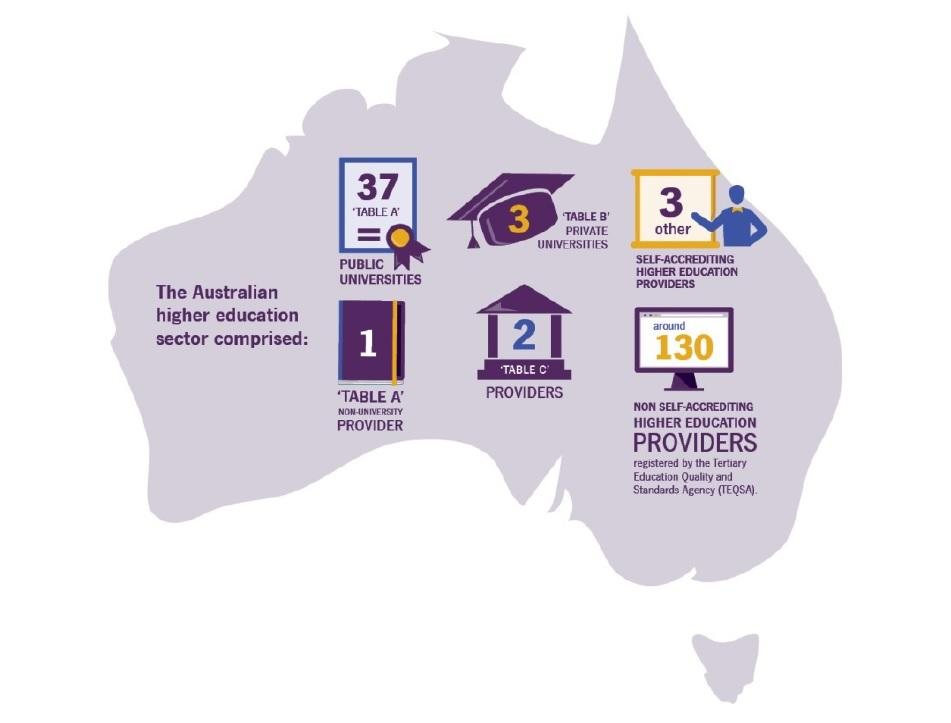Draw attention to some important aspects in this diagram. There are six universities or providers listed under the Australian higher education sector. 